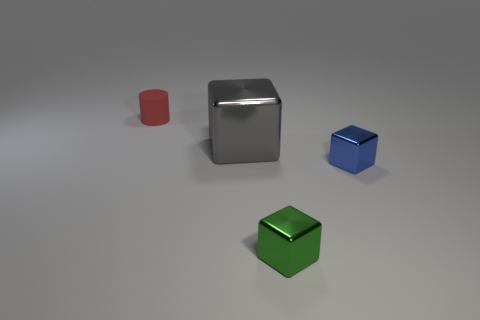Add 3 large yellow matte spheres. How many objects exist? 7 Subtract all cylinders. How many objects are left? 3 Add 1 matte cylinders. How many matte cylinders exist? 2 Subtract 0 blue cylinders. How many objects are left? 4 Subtract all rubber things. Subtract all green metal objects. How many objects are left? 2 Add 1 tiny green shiny blocks. How many tiny green shiny blocks are left? 2 